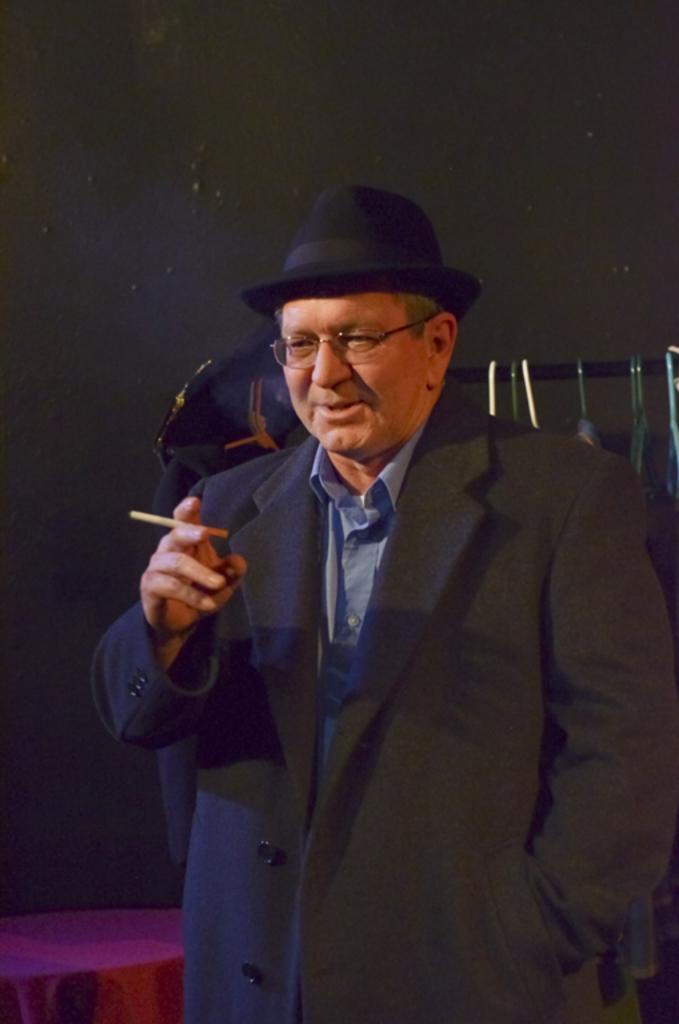Can you describe this image briefly? In this image there is a person wearing jacket and he is holding a cigarette in his hand. He is wearing spectacles and cap. Behind him there is a rod having few hangers which are having clothes on it. Left bottom there is a table having cloth on it. Background there is a wall. 